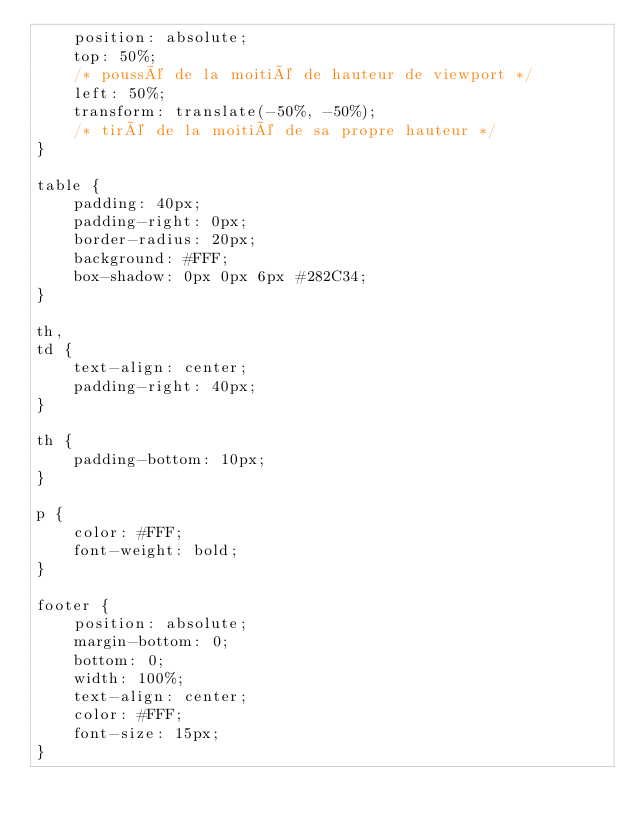Convert code to text. <code><loc_0><loc_0><loc_500><loc_500><_CSS_>    position: absolute;
    top: 50%;
    /* poussé de la moitié de hauteur de viewport */
    left: 50%;
    transform: translate(-50%, -50%);
    /* tiré de la moitié de sa propre hauteur */
}

table {
    padding: 40px;
    padding-right: 0px;
    border-radius: 20px;
    background: #FFF;
    box-shadow: 0px 0px 6px #282C34;
}

th,
td {
    text-align: center;
    padding-right: 40px;
}

th {
    padding-bottom: 10px;
}

p {
    color: #FFF;
    font-weight: bold;
}

footer {
    position: absolute;
    margin-bottom: 0;
    bottom: 0;
    width: 100%;
    text-align: center;
    color: #FFF;
    font-size: 15px;
}</code> 